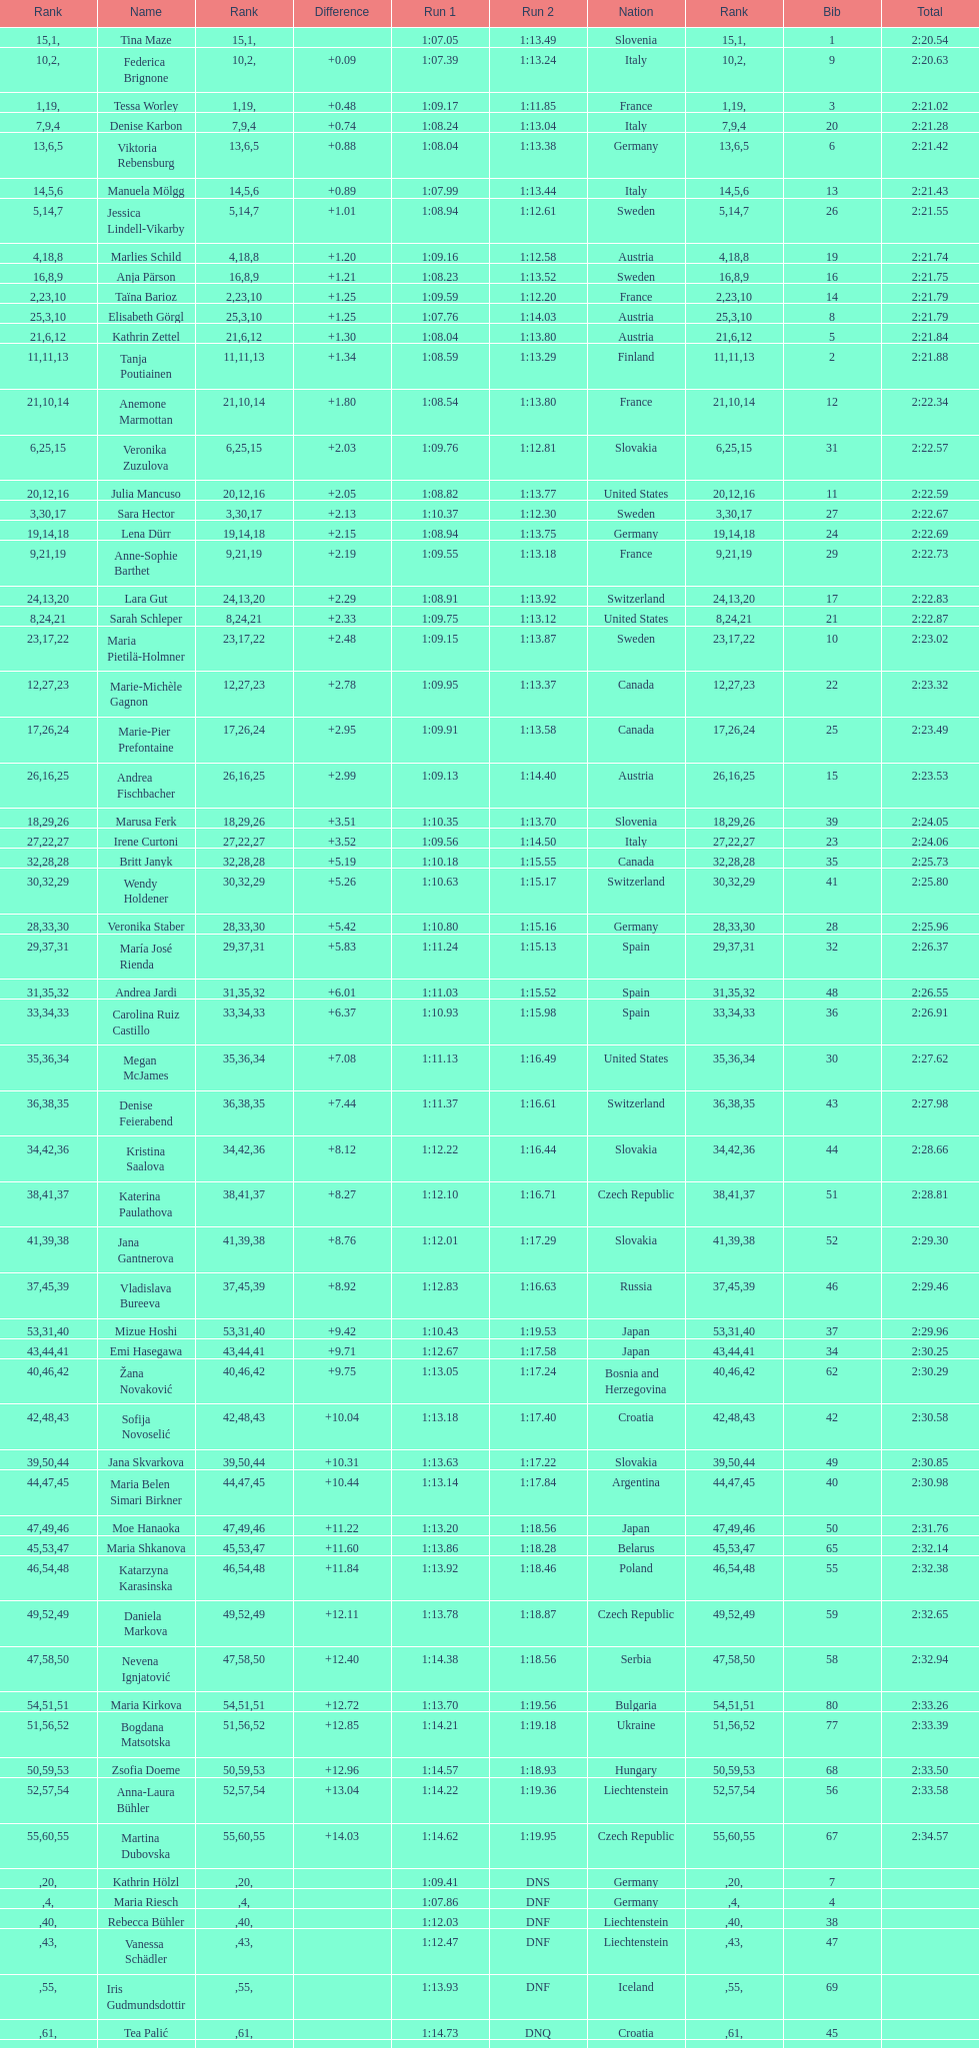How many total names are there? 116. 